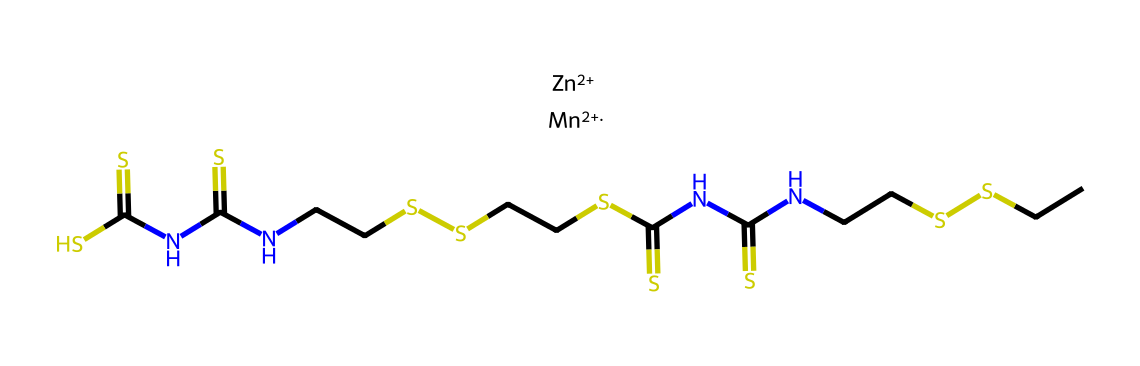What is the main metal present in the chemical structure? The chemical structure includes zinc, denoted by the symbol Zn+2 at the beginning of the SMILES representation. This indicates that zinc is one of the metal components in mancozeb.
Answer: zinc How many nitrogen atoms are present in the structure? By analyzing the SMILES, there are four instances of nitrogen represented by the letter "N." Counting these gives a total of four nitrogen atoms in the compound.
Answer: four What type of chemical compounds does mancozeb belong to? Mancozeb is classified as a dithiocarbamate fungicide, which can be inferred from the presence of the "NC(=S)" groups and the dithiocarbamate structure characteristics in the SMILES.
Answer: dithiocarbamate How many sulfide (S) groups are in the structure? Counting the occurrences of the letter "S" in the chemical structure reveals a total of six sulfide (S) groups.
Answer: six What function does the zinc ion serve in this chemical? The zinc ion acts as a metal ion coordination center in mancozeb, which is common in fungicides to enhance their efficacy by facilitating binding to targets in the fungal cells.
Answer: coordination center What is the total number of carbon atoms in the structure? By counting the occurrences of the letter "C" in the SMILES string, we find that there are a total of twelve carbon atoms present in the chemical structure.
Answer: twelve 